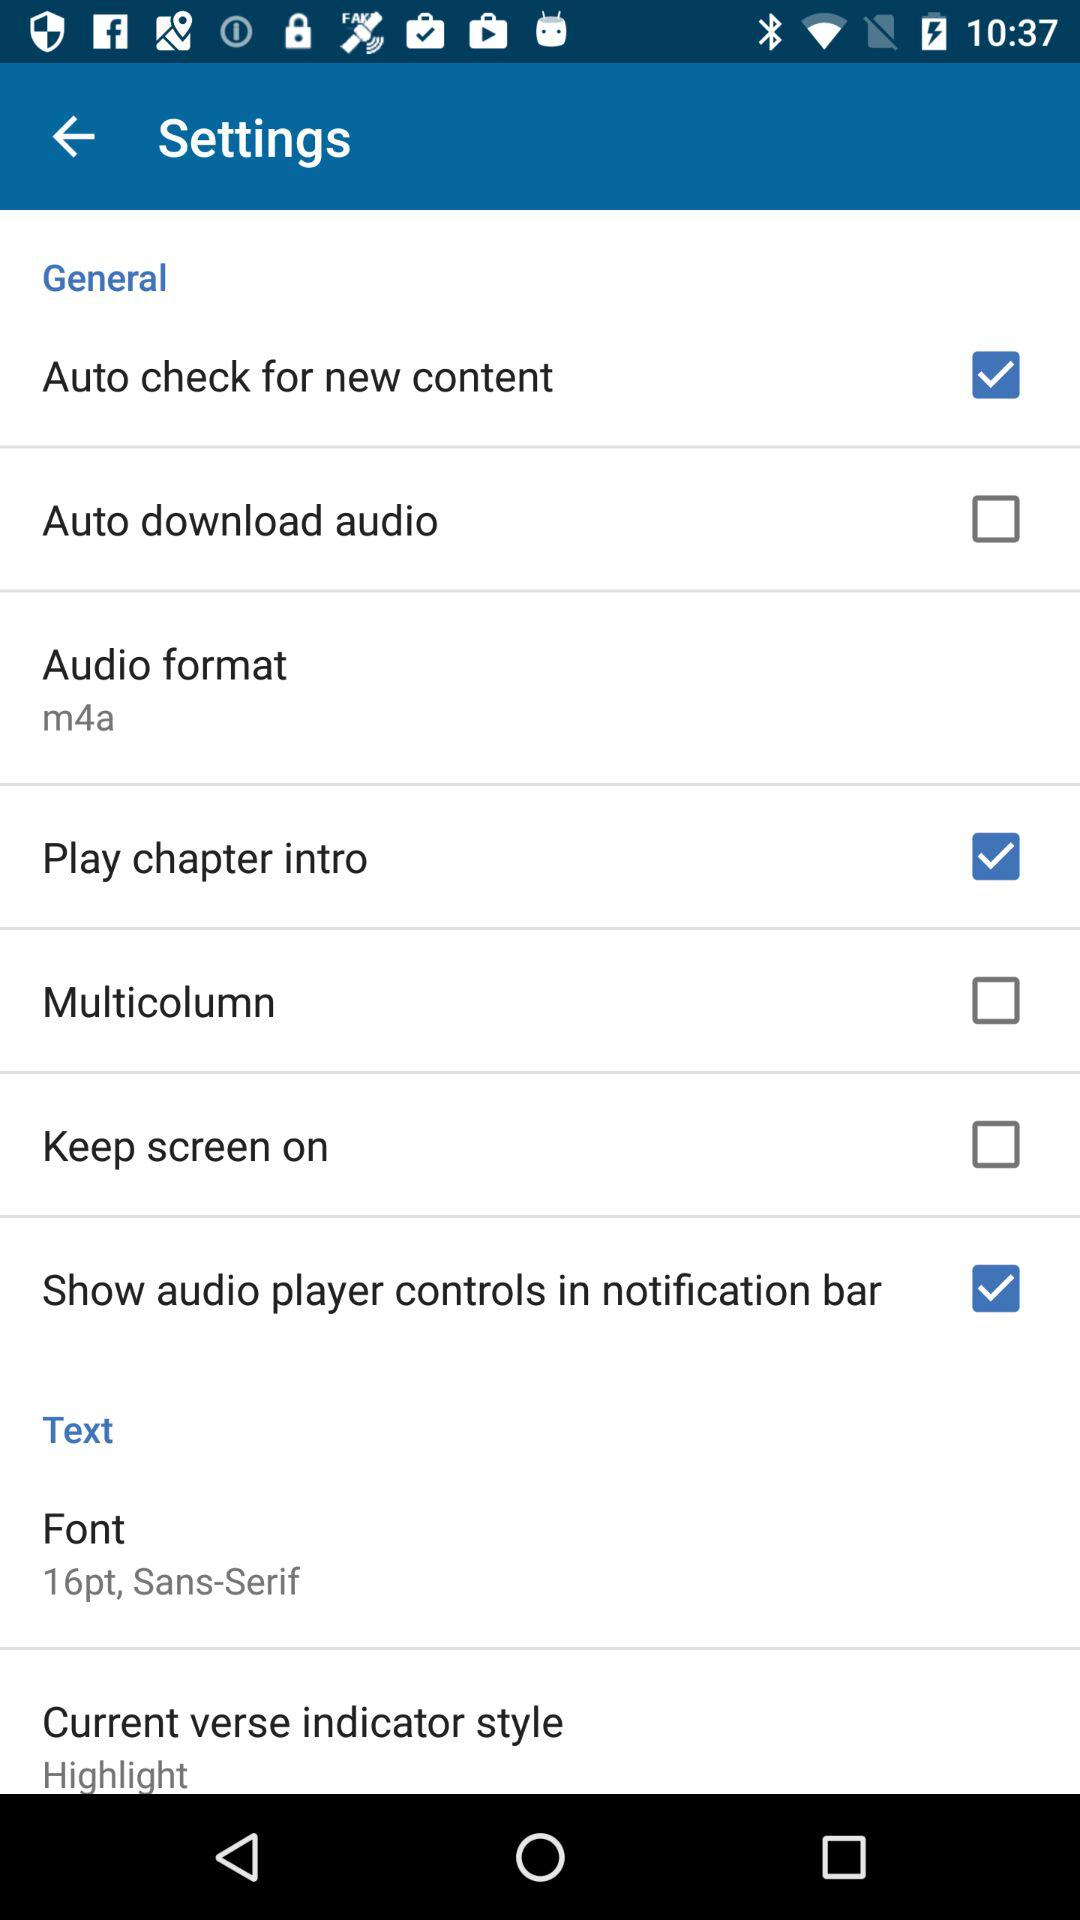What is the status of the "Play chapter intro"? The status of the "Play chapter intro" is "on". 